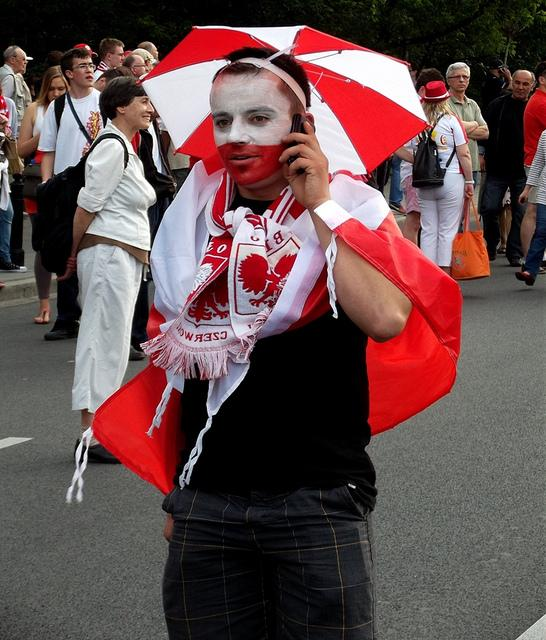Which country has red with white flag? Please explain your reasoning. poland. Poland's flag is red and white. 